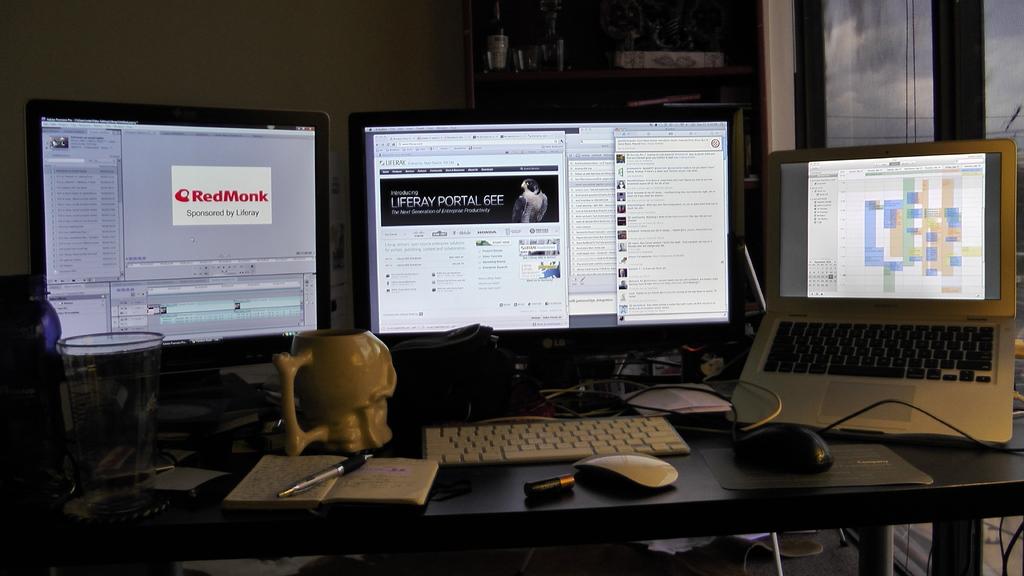What company logo is spelled out on the very left monitor written in red?
Offer a very short reply. Redmonk. 